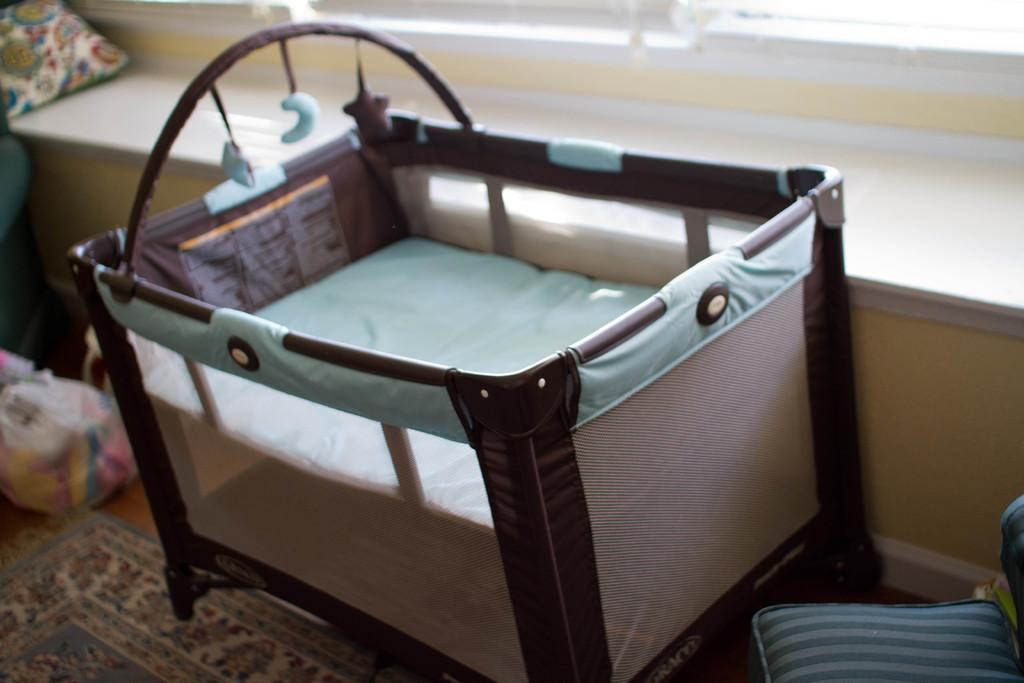What type of floor covering is visible in the image? There is a carpet in the image. What object can be seen near the crib in the image? There is a bag in the image. What piece of furniture is on the floor in the image? There is a crib on the floor in the image. Can you describe the pillow in the image? There is a pillow on a platform in the background of the image. How many people are in the crowd in the image? There is no crowd present in the image; it features a carpet, a bag, a crib, and a pillow. What type of thought is being expressed by the sofa in the image? There is no sofa present in the image, and thoughts cannot be expressed by inanimate objects. 